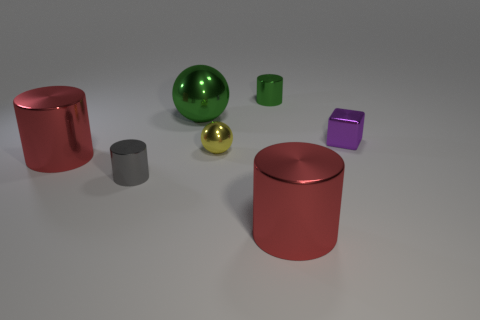What is the color of the cube that is the same material as the large green thing?
Make the answer very short. Purple. Is the number of green matte cylinders less than the number of cubes?
Your response must be concise. Yes. How many purple objects are big spheres or small things?
Ensure brevity in your answer.  1. What number of metallic things are to the right of the large green shiny object and behind the small purple shiny cube?
Offer a terse response. 1. Do the yellow thing and the gray cylinder have the same material?
Give a very brief answer. Yes. What is the shape of the green thing that is the same size as the purple object?
Offer a very short reply. Cylinder. Are there more tiny purple metal things than large purple spheres?
Keep it short and to the point. Yes. There is a tiny object that is left of the cube and on the right side of the yellow metallic object; what is it made of?
Offer a very short reply. Metal. How many other objects are the same material as the tiny green thing?
Your answer should be very brief. 6. What number of small metallic cylinders have the same color as the big sphere?
Keep it short and to the point. 1. 